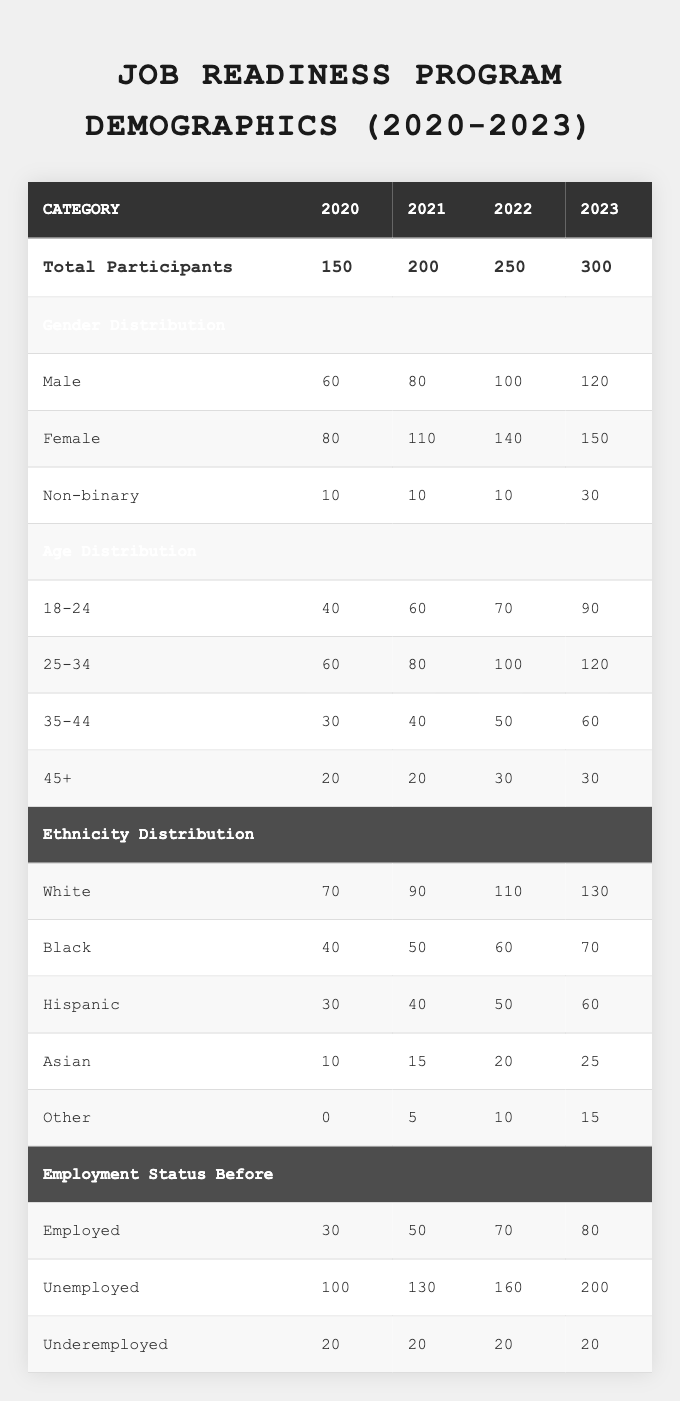What was the total number of participants in 2022? The total number of participants in 2022 is directly provided in the table under the "Total Participants" row for that year, which is 250.
Answer: 250 What is the percentage of male participants in 2021? In 2021, there were 80 male participants out of a total of 200 participants. To calculate the percentage, divide 80 by 200 and then multiply by 100, giving (80/200) * 100 = 40%.
Answer: 40% Did the number of female participants increase from 2020 to 2023? The number of female participants in 2020 was 80, and in 2023 it increased to 150. Since 150 is greater than 80, the answer is yes.
Answer: Yes What is the age distribution for participants aged 35-44 in 2022 and 2023 combined? The number of participants aged 35-44 in 2022 is 50 and in 2023 is 60. Adding these together gives 50 + 60 = 110.
Answer: 110 How many unemployed participants were there in 2020 and 2021 combined? In 2020, there were 100 unemployed participants, and in 2021 there were 130. Adding these two numbers together gives 100 + 130 = 230.
Answer: 230 What is the difference in the number of Hispanic participants between 2020 and 2023? In 2020, there were 30 Hispanic participants, and in 2023, there are 60. The difference is 60 - 30 = 30.
Answer: 30 Was there an increase in the number of non-binary participants from 2020 to 2023? The number of non-binary participants in 2020 was 10, and in 2023 it increased to 30. Since 30 is greater than 10, the answer is yes.
Answer: Yes What was the average number of participants in the age group 25-34 over the four years? To find the average, we add the number of participants in the 25-34 age group for each year: 60 (2020) + 80 (2021) + 100 (2022) + 120 (2023) = 360. Then divide by 4, giving an average of 360 / 4 = 90.
Answer: 90 What is the total number of employed participants from 2020 to 2023? The number of employed participants for each year is: 30 (2020) + 50 (2021) + 70 (2022) + 80 (2023). Adding these gives a total of 30 + 50 + 70 + 80 = 230.
Answer: 230 Is the total number of participants in 2023 greater than in 2022? The total number of participants in 2022 is 250, and in 2023 it is 300. Since 300 is greater than 250, the answer is yes.
Answer: Yes 